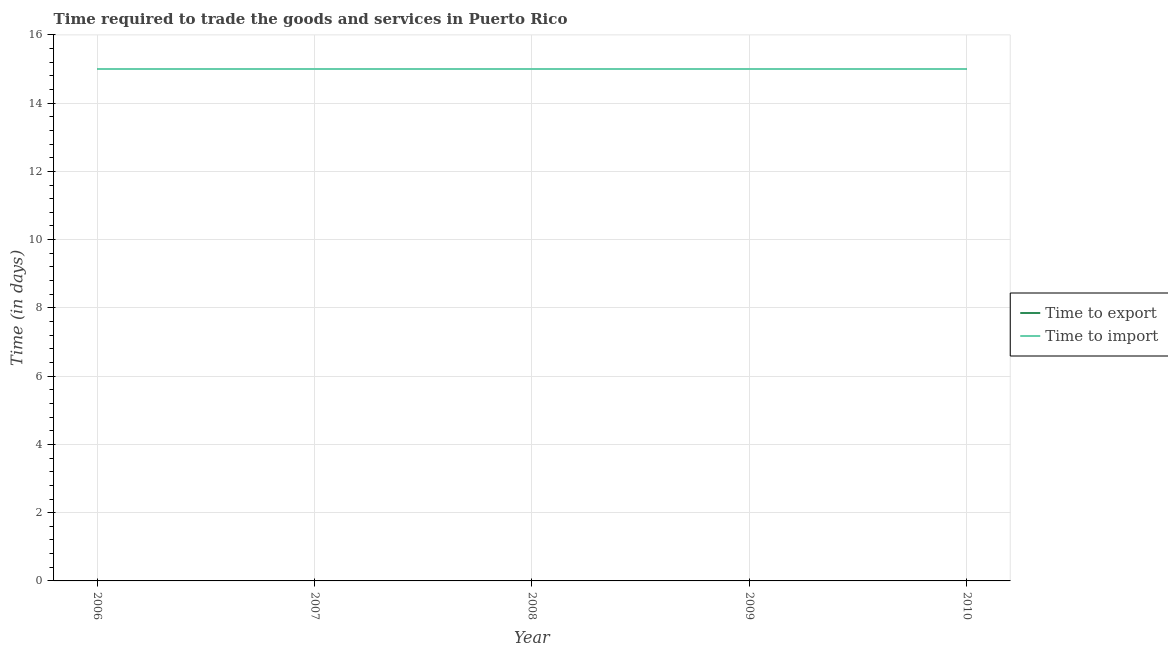Does the line corresponding to time to import intersect with the line corresponding to time to export?
Offer a terse response. Yes. What is the time to import in 2010?
Make the answer very short. 15. Across all years, what is the maximum time to import?
Make the answer very short. 15. Across all years, what is the minimum time to import?
Provide a short and direct response. 15. In which year was the time to import maximum?
Offer a terse response. 2006. In which year was the time to import minimum?
Offer a terse response. 2006. What is the total time to export in the graph?
Your answer should be compact. 75. What is the difference between the time to import in 2006 and that in 2008?
Offer a very short reply. 0. What is the average time to export per year?
Offer a terse response. 15. In the year 2007, what is the difference between the time to export and time to import?
Give a very brief answer. 0. In how many years, is the time to import greater than 15.6 days?
Ensure brevity in your answer.  0. What is the ratio of the time to import in 2007 to that in 2010?
Provide a succinct answer. 1. Is the time to import in 2006 less than that in 2009?
Provide a succinct answer. No. Is the difference between the time to import in 2006 and 2009 greater than the difference between the time to export in 2006 and 2009?
Make the answer very short. No. What is the difference between the highest and the second highest time to import?
Provide a succinct answer. 0. What is the difference between the highest and the lowest time to export?
Offer a very short reply. 0. In how many years, is the time to export greater than the average time to export taken over all years?
Make the answer very short. 0. Is the sum of the time to export in 2006 and 2008 greater than the maximum time to import across all years?
Provide a short and direct response. Yes. Does the time to import monotonically increase over the years?
Make the answer very short. No. Is the time to import strictly less than the time to export over the years?
Your response must be concise. No. How many lines are there?
Your answer should be very brief. 2. Does the graph contain grids?
Ensure brevity in your answer.  Yes. How are the legend labels stacked?
Give a very brief answer. Vertical. What is the title of the graph?
Provide a short and direct response. Time required to trade the goods and services in Puerto Rico. Does "From production" appear as one of the legend labels in the graph?
Provide a succinct answer. No. What is the label or title of the X-axis?
Give a very brief answer. Year. What is the label or title of the Y-axis?
Your answer should be very brief. Time (in days). What is the Time (in days) in Time to export in 2006?
Your response must be concise. 15. What is the Time (in days) of Time to import in 2007?
Make the answer very short. 15. What is the Time (in days) of Time to export in 2008?
Ensure brevity in your answer.  15. What is the Time (in days) of Time to import in 2008?
Your answer should be very brief. 15. What is the Time (in days) of Time to import in 2009?
Offer a terse response. 15. What is the Time (in days) in Time to export in 2010?
Keep it short and to the point. 15. Across all years, what is the minimum Time (in days) of Time to import?
Provide a succinct answer. 15. What is the total Time (in days) of Time to export in the graph?
Give a very brief answer. 75. What is the difference between the Time (in days) of Time to export in 2006 and that in 2007?
Your response must be concise. 0. What is the difference between the Time (in days) of Time to export in 2006 and that in 2008?
Give a very brief answer. 0. What is the difference between the Time (in days) in Time to import in 2006 and that in 2008?
Give a very brief answer. 0. What is the difference between the Time (in days) of Time to export in 2006 and that in 2009?
Your answer should be very brief. 0. What is the difference between the Time (in days) in Time to import in 2006 and that in 2010?
Provide a short and direct response. 0. What is the difference between the Time (in days) of Time to import in 2007 and that in 2009?
Provide a short and direct response. 0. What is the difference between the Time (in days) of Time to import in 2007 and that in 2010?
Your answer should be compact. 0. What is the difference between the Time (in days) in Time to export in 2008 and that in 2009?
Provide a short and direct response. 0. What is the difference between the Time (in days) in Time to import in 2008 and that in 2009?
Your answer should be compact. 0. What is the difference between the Time (in days) of Time to export in 2006 and the Time (in days) of Time to import in 2009?
Keep it short and to the point. 0. What is the difference between the Time (in days) in Time to export in 2008 and the Time (in days) in Time to import in 2009?
Your answer should be compact. 0. What is the average Time (in days) of Time to import per year?
Your response must be concise. 15. In the year 2007, what is the difference between the Time (in days) of Time to export and Time (in days) of Time to import?
Your answer should be compact. 0. In the year 2008, what is the difference between the Time (in days) of Time to export and Time (in days) of Time to import?
Make the answer very short. 0. In the year 2010, what is the difference between the Time (in days) in Time to export and Time (in days) in Time to import?
Your answer should be compact. 0. What is the ratio of the Time (in days) in Time to import in 2006 to that in 2007?
Your response must be concise. 1. What is the ratio of the Time (in days) in Time to export in 2006 to that in 2009?
Give a very brief answer. 1. What is the ratio of the Time (in days) of Time to export in 2006 to that in 2010?
Offer a terse response. 1. What is the ratio of the Time (in days) of Time to export in 2007 to that in 2009?
Your answer should be very brief. 1. What is the ratio of the Time (in days) in Time to import in 2007 to that in 2009?
Provide a succinct answer. 1. What is the ratio of the Time (in days) in Time to import in 2007 to that in 2010?
Offer a very short reply. 1. What is the ratio of the Time (in days) in Time to export in 2008 to that in 2009?
Give a very brief answer. 1. What is the ratio of the Time (in days) in Time to import in 2008 to that in 2009?
Ensure brevity in your answer.  1. What is the ratio of the Time (in days) of Time to export in 2008 to that in 2010?
Keep it short and to the point. 1. What is the ratio of the Time (in days) in Time to export in 2009 to that in 2010?
Your response must be concise. 1. What is the ratio of the Time (in days) in Time to import in 2009 to that in 2010?
Provide a short and direct response. 1. What is the difference between the highest and the second highest Time (in days) of Time to export?
Offer a very short reply. 0. What is the difference between the highest and the second highest Time (in days) of Time to import?
Offer a terse response. 0. What is the difference between the highest and the lowest Time (in days) of Time to export?
Your answer should be very brief. 0. What is the difference between the highest and the lowest Time (in days) in Time to import?
Offer a terse response. 0. 